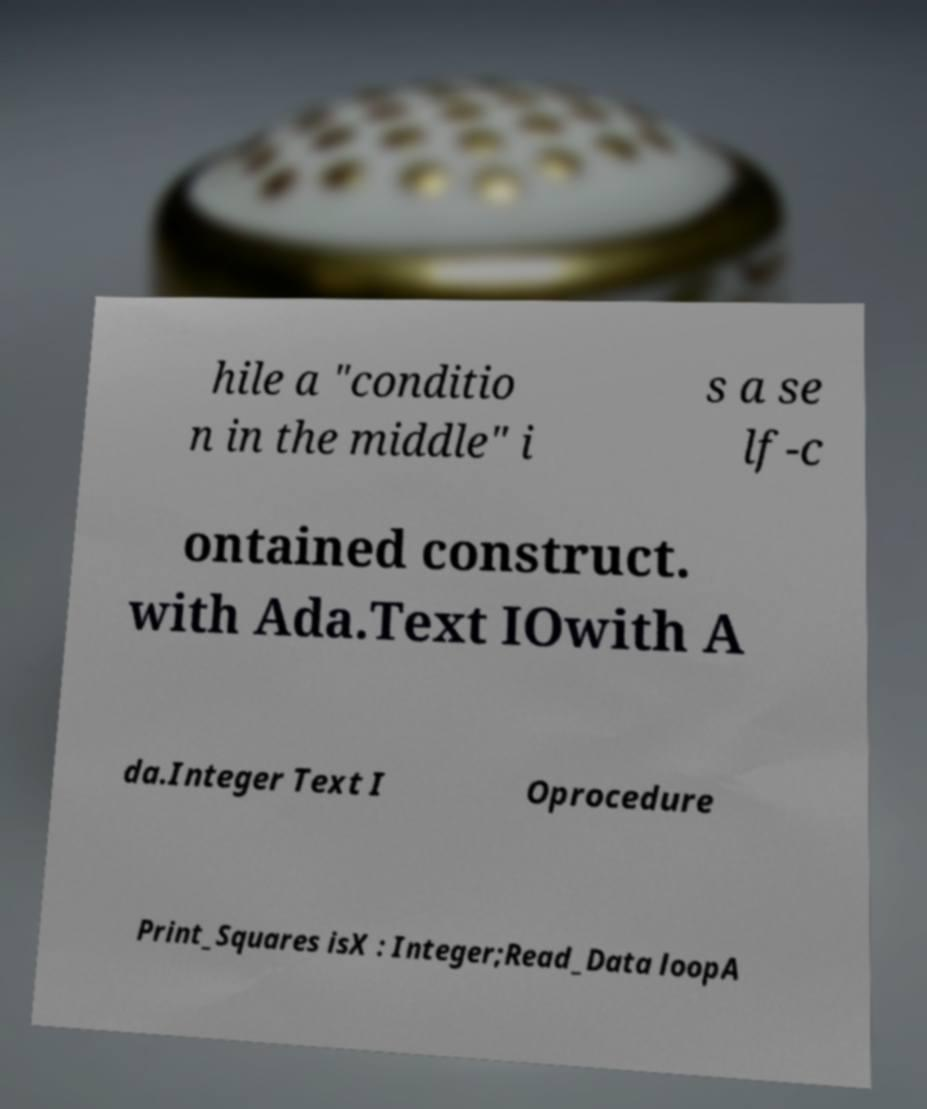What messages or text are displayed in this image? I need them in a readable, typed format. hile a "conditio n in the middle" i s a se lf-c ontained construct. with Ada.Text IOwith A da.Integer Text I Oprocedure Print_Squares isX : Integer;Read_Data loopA 